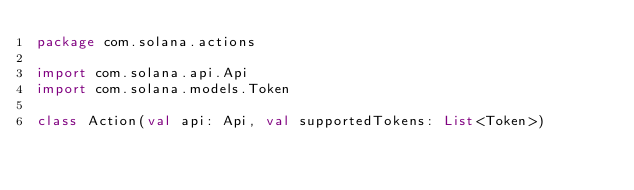<code> <loc_0><loc_0><loc_500><loc_500><_Kotlin_>package com.solana.actions

import com.solana.api.Api
import com.solana.models.Token

class Action(val api: Api, val supportedTokens: List<Token>)
</code> 